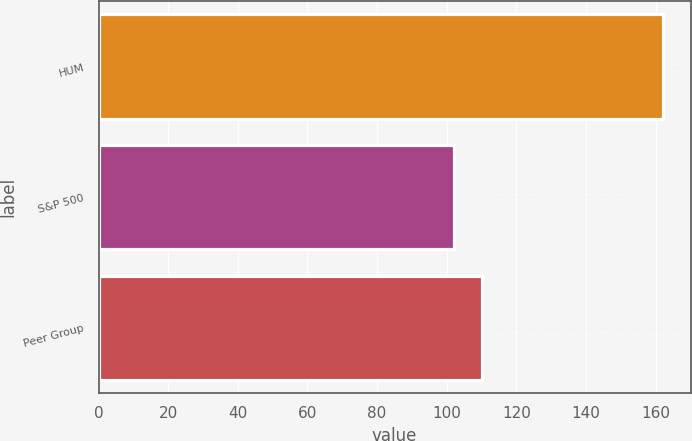<chart> <loc_0><loc_0><loc_500><loc_500><bar_chart><fcel>HUM<fcel>S&P 500<fcel>Peer Group<nl><fcel>162<fcel>102<fcel>110<nl></chart> 